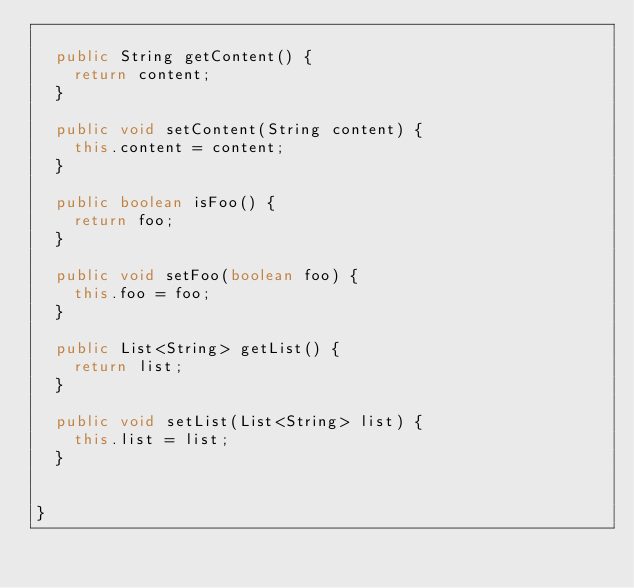<code> <loc_0><loc_0><loc_500><loc_500><_Java_>
	public String getContent() {
		return content;
	}

	public void setContent(String content) {
		this.content = content;
	}

	public boolean isFoo() {
		return foo;
	}

	public void setFoo(boolean foo) {
		this.foo = foo;
	}

	public List<String> getList() {
		return list;
	}

	public void setList(List<String> list) {
		this.list = list;
	}
	
	
}
</code> 